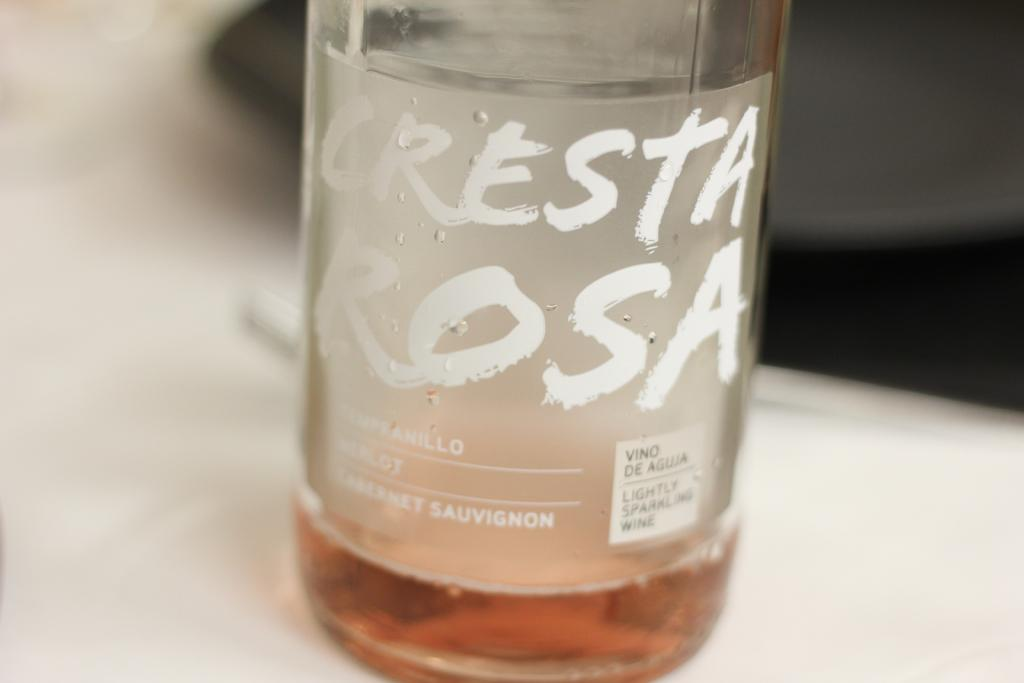<image>
Write a terse but informative summary of the picture. A printed label on a bottle of Cresta Rosa says that it is a LIGHTLY SPARKLING WINE. 